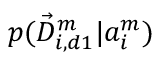<formula> <loc_0><loc_0><loc_500><loc_500>p ( \vec { D } _ { i , d 1 } ^ { m } | a _ { i } ^ { m } )</formula> 